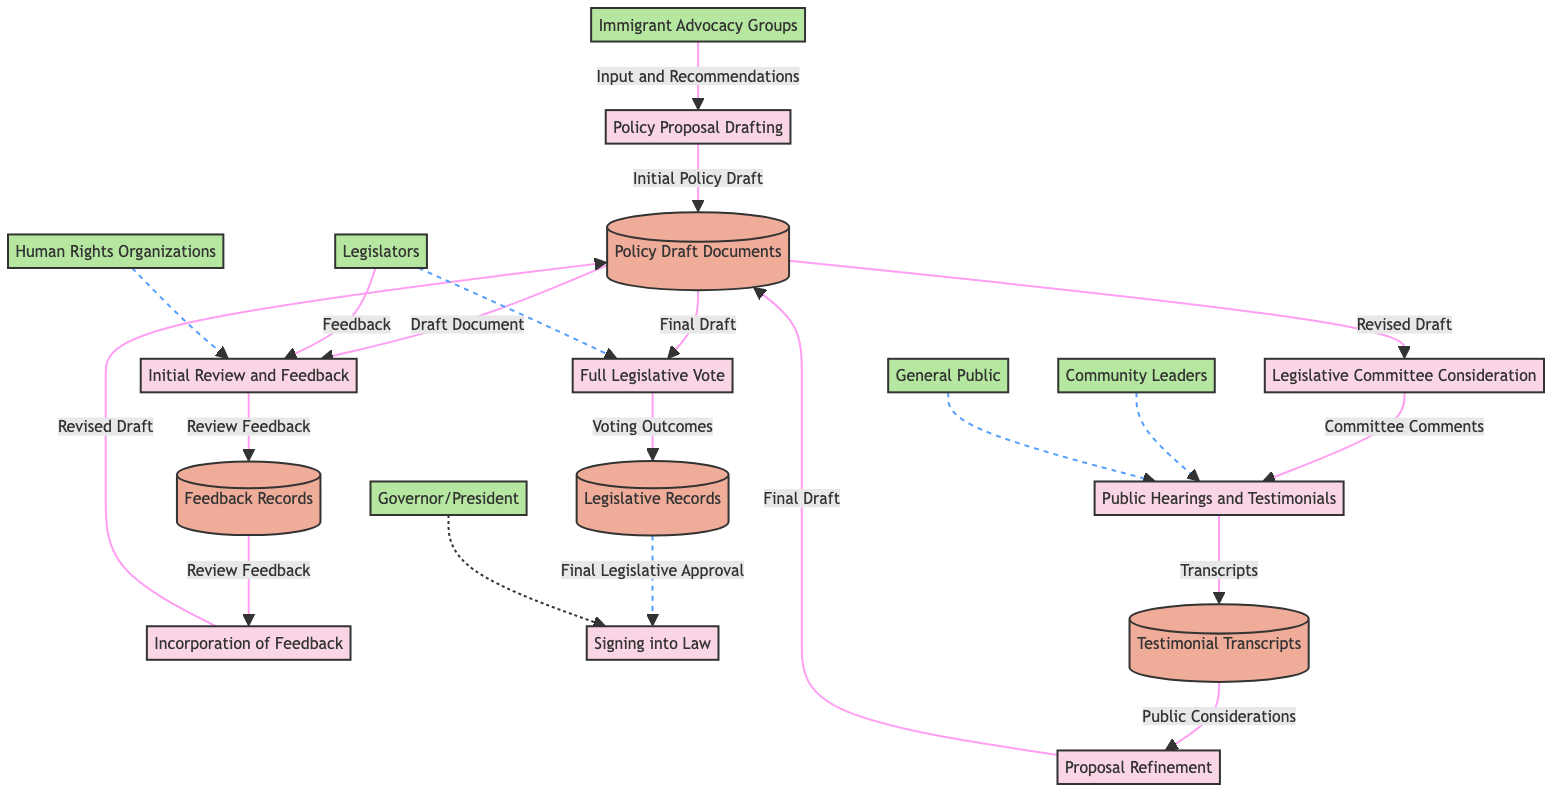What is the first process in the diagram? The first process listed is "Policy Proposal Drafting," which is where the initial draft of the immigration policy proposal is created. This is indicated at the top of the diagram as the starting point of the flow.
Answer: Policy Proposal Drafting How many external entities are involved in the diagram? There are six external entities listed: Immigrant Advocacy Groups, Human Rights Organizations, Community Leaders, General Public, Legislators, and Governor/President. These entities contribute input or have a role in the process.
Answer: 6 What data flows from "Public Hearings and Testimonials" to "Testimonial Transcripts"? The data flowing from "Public Hearings and Testimonials" to "Testimonial Transcripts" is mentioned as "Transcripts," which indicates that the transcripts of the public testimonials are stored in that repository.
Answer: Transcripts Which process involves the participation of both "Legislators" and "Legislative Committee"? The process "Public Hearings and Testimonials" involves participation from the Legislative Committee, who holds the hearings, and Legislators who provide feedback and reviews during the overall process.
Answer: Public Hearings and Testimonials What document is produced after the "Full Legislative Vote"? After the "Full Legislative Vote" process, the document produced is recorded as "Voting Outcomes," which are then stored in the Legislative Records repository.
Answer: Voting Outcomes Which process includes "Input and Recommendations" from external entities? The "Policy Proposal Drafting" process includes "Input and Recommendations" from external entities, specifically from Immigrant Advocacy Groups and other relevant stakeholders.
Answer: Policy Proposal Drafting What is the final output of the legislative process in this diagram? The final output of the legislative process in this diagram is the action of signing the proposal into law at the end of the process, as represented in the "Signing into Law" process.
Answer: Signing into Law What do "Feedback Records" feed into in the process? "Feedback Records" provide data that feeds into the "Incorporation of Feedback" process, where the feedback collected is analyzed and incorporated into the proposal draft.
Answer: Incorporation of Feedback How is the revised draft associated with the "Legislative Committee Consideration"? The revised draft is associated with "Legislative Committee Consideration" as it is sent from the "Policy Draft Documents" and is a crucial component for discussing the proposal in the legislative committee.
Answer: Legislative Committee Consideration 